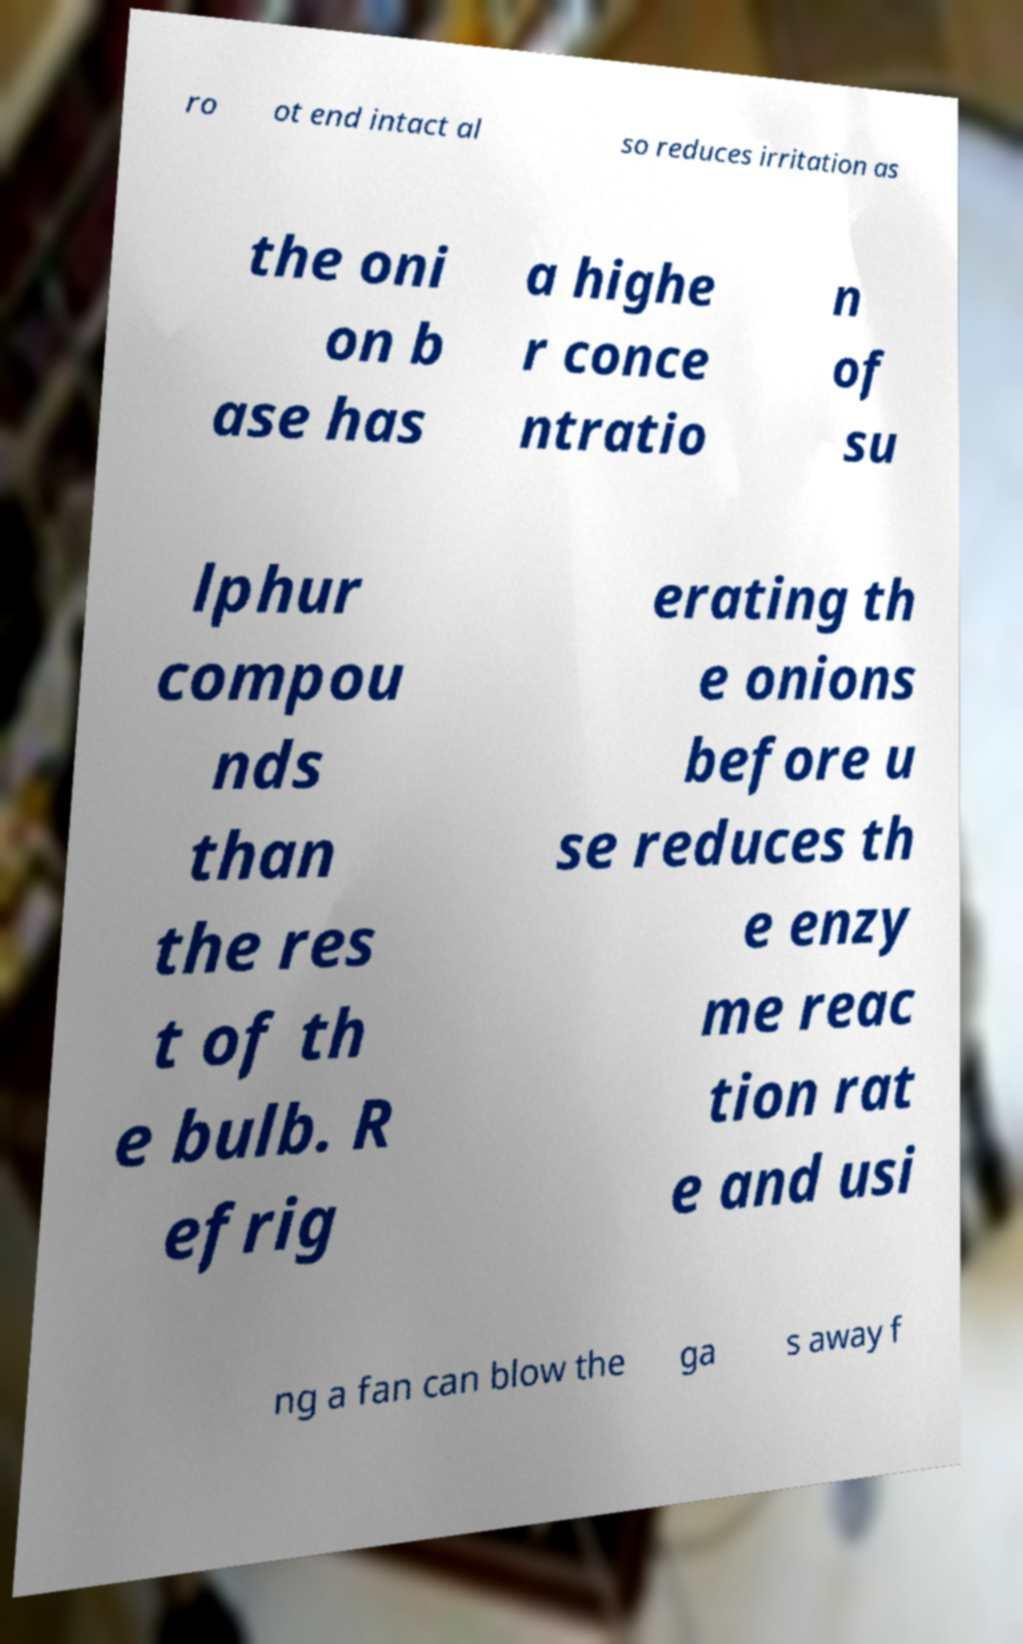I need the written content from this picture converted into text. Can you do that? ro ot end intact al so reduces irritation as the oni on b ase has a highe r conce ntratio n of su lphur compou nds than the res t of th e bulb. R efrig erating th e onions before u se reduces th e enzy me reac tion rat e and usi ng a fan can blow the ga s away f 